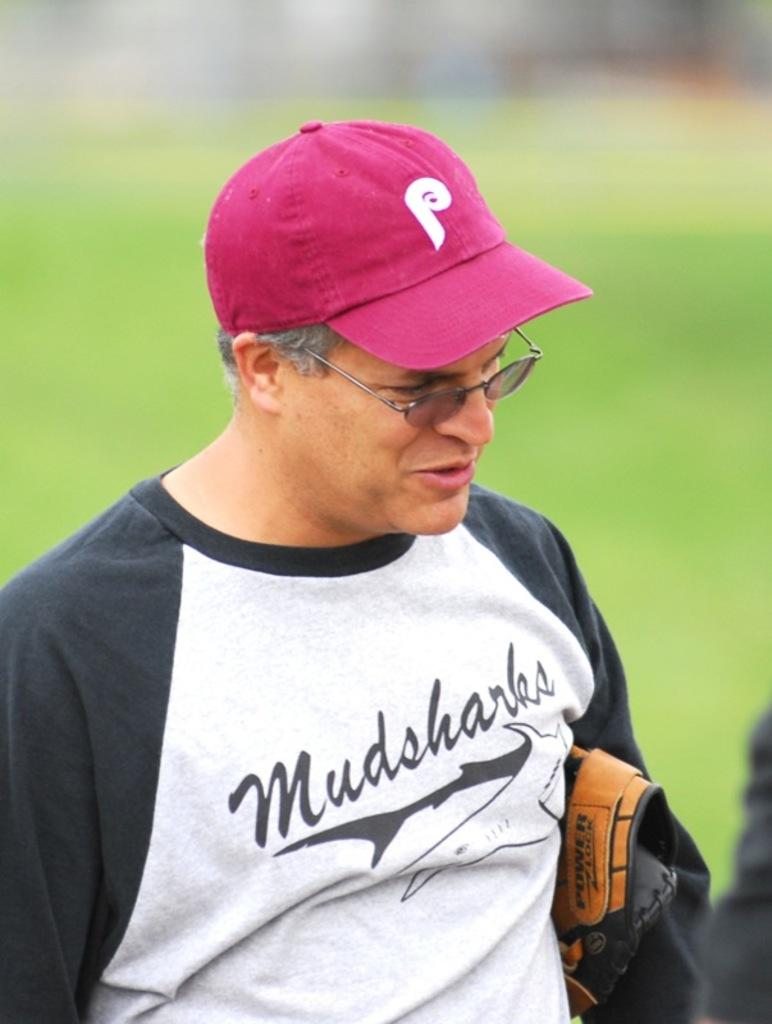<image>
Summarize the visual content of the image. A man in a black and white top with the letter P on his baseball cap. 